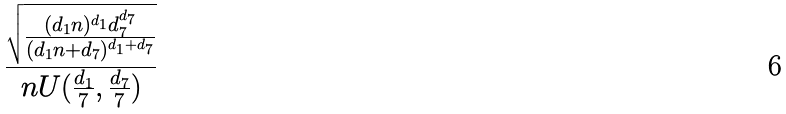<formula> <loc_0><loc_0><loc_500><loc_500>\frac { \sqrt { \frac { ( d _ { 1 } n ) ^ { d _ { 1 } } d _ { 7 } ^ { d _ { 7 } } } { ( d _ { 1 } n + d _ { 7 } ) ^ { d _ { 1 } + d _ { 7 } } } } } { n U ( \frac { d _ { 1 } } { 7 } , \frac { d _ { 7 } } { 7 } ) }</formula> 